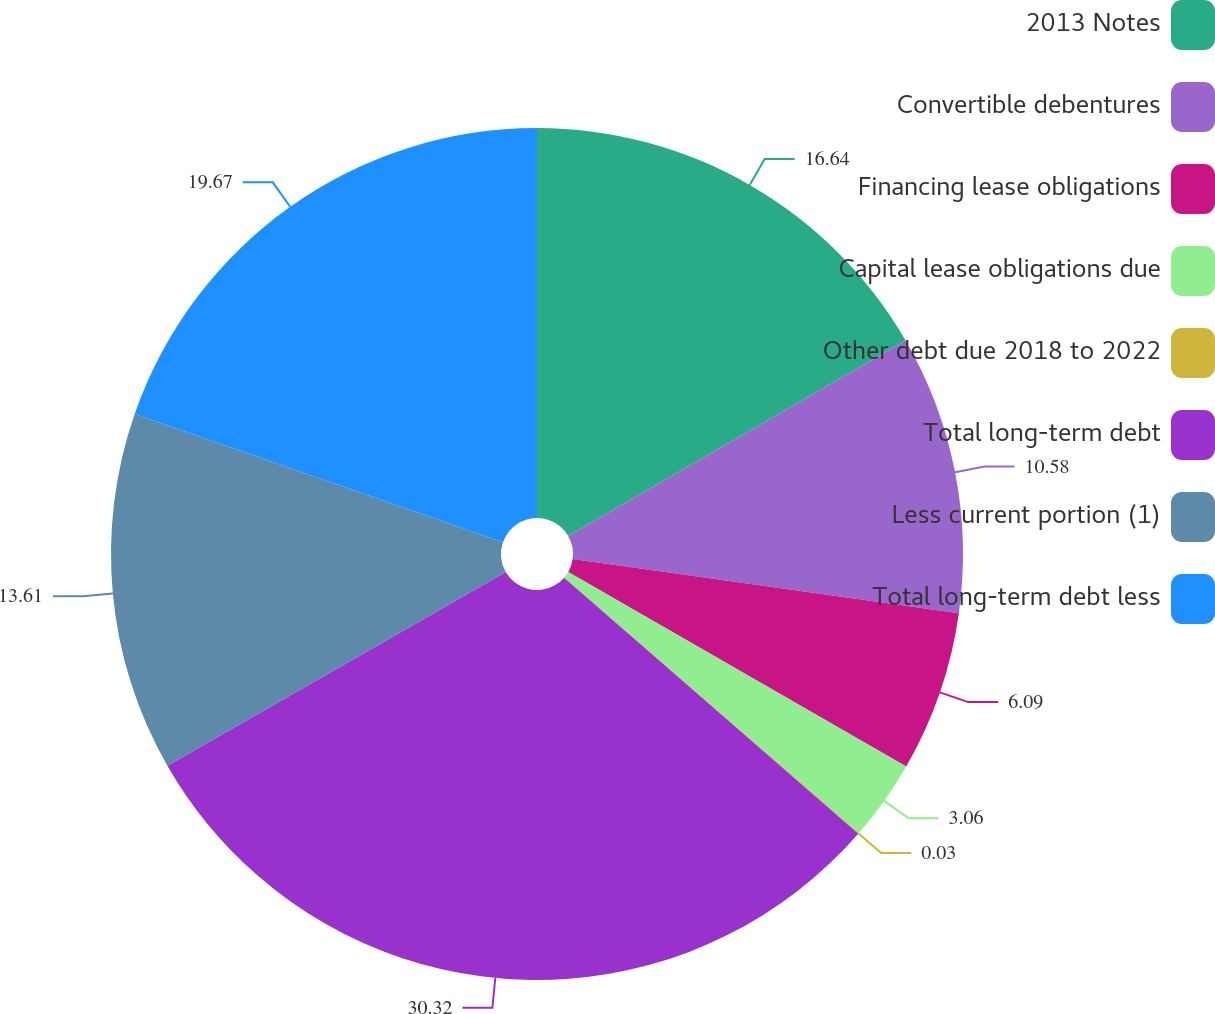<chart> <loc_0><loc_0><loc_500><loc_500><pie_chart><fcel>2013 Notes<fcel>Convertible debentures<fcel>Financing lease obligations<fcel>Capital lease obligations due<fcel>Other debt due 2018 to 2022<fcel>Total long-term debt<fcel>Less current portion (1)<fcel>Total long-term debt less<nl><fcel>16.64%<fcel>10.58%<fcel>6.09%<fcel>3.06%<fcel>0.03%<fcel>30.32%<fcel>13.61%<fcel>19.67%<nl></chart> 